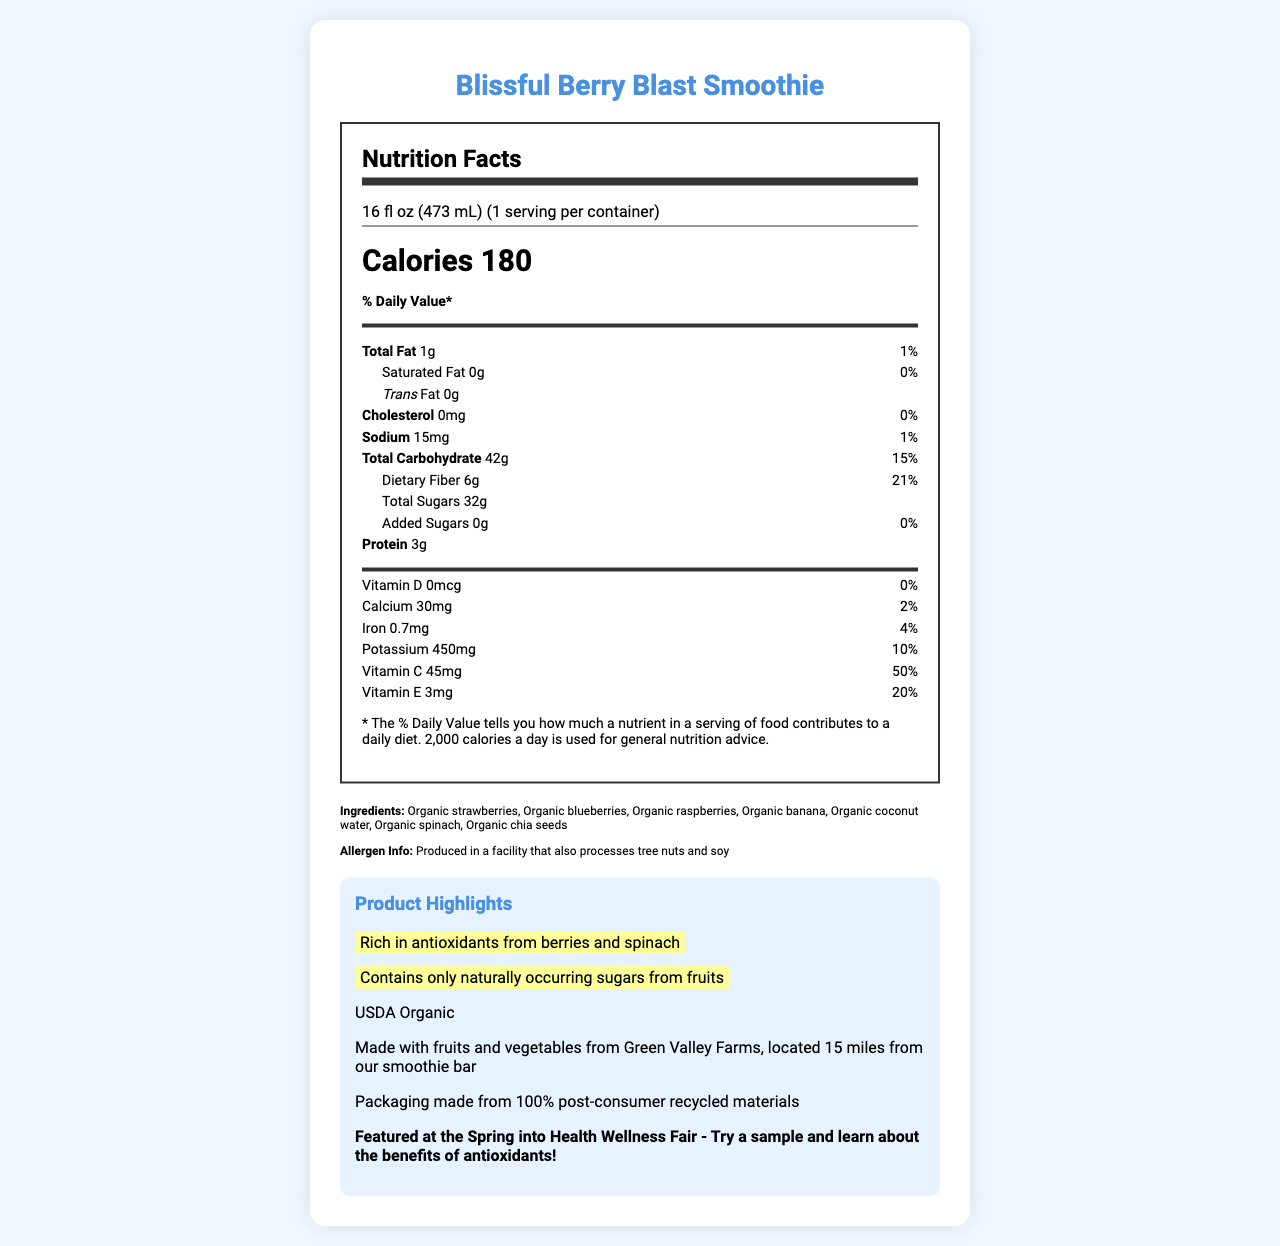what is the serving size for the Blissful Berry Blast Smoothie? The document states that the serving size is 16 fl oz (473 mL).
Answer: 16 fl oz (473 mL) how many calories are in one serving of the smoothie? The calorie count per serving is noted as 180 in the document.
Answer: 180 what is the % daily value of dietary fiber in one serving? The document lists that one serving contains 21% of the daily value of dietary fiber.
Answer: 21% are there any added sugars in the smoothie? The document specifies that the amount of added sugars is 0g, which corresponds to 0% of the daily value.
Answer: No which ingredients in the smoothie contribute to its antioxidant content? The document highlights that the smoothie is rich in antioxidants from berries and spinach.
Answer: Organic strawberries, organic blueberries, organic raspberries, organic spinach where are the fruits and vegetables sourced from for this product? The document mentions that the fruits and vegetables are sourced from Green Valley Farms.
Answer: Green Valley Farms how many grams of protein are in one serving of the smoothie? The document states that there are 3 grams of protein per serving.
Answer: 3g which nutrient has the highest % daily value in the smoothie? A. Vitamin D B. Vitamin C C. Iron D. Vitamin E Vitamin C has a % daily value of 50%, which is the highest among the listed nutrients.
Answer: B. Vitamin C what is the amount of calcium in one serving? A. 10mg B. 20mg C. 30mg D. 40mg According to the document, the amount of calcium in one serving is 30mg.
Answer: C. 30mg does the smoothie contain any cholesterol? The document indicates 0mg of cholesterol, meaning there is no cholesterol in the product.
Answer: No describe the main idea of the document The document focuses on giving a complete nutritional profile of the smoothie, highlights its health benefits, sourcing, and environmental impact, and promotes its presence at a local wellness fair.
Answer: The document provides detailed nutritional information about the Blissful Berry Blast Smoothie, emphasizing its natural sugar content, antioxidants, and organic ingredients. It highlights the product's health benefits, local sourcing from Green Valley Farms, and its environmentally friendly packaging. The smoothie will be featured at the Spring into Health Wellness Fair. is the packaging of the smoothie environmentally friendly? The document states that the packaging is made from 100% post-consumer recycled materials, indicating it is environmentally friendly.
Answer: Yes what is the total carbohydrate content in one serving? The total carbohydrate content per serving is listed as 42g in the document.
Answer: 42g how much sodium is in one serving? The document shows that one serving contains 15mg of sodium.
Answer: 15mg what type of certification does the smoothie have? The document mentions that the Blissful Berry Blast Smoothie is USDA Organic certified.
Answer: USDA Organic what is the recommended daily calorie intake used for general nutrition advice according to the document? The document specifies that 2,000 calories a day is used for general nutrition advice.
Answer: 2,000 calories is there any information about the production facility's allergen processing? The document states that the product is produced in a facility that also processes tree nuts and soy.
Answer: Yes what is the natural sugar content in the smoothie? The document emphasizes that the smoothie contains only naturally occurring sugars from the fruits used in it.
Answer: Contains only naturally occurring sugars from fruits which vitamins have specific amounts and % daily values listed? The document lists specific amounts and % daily values for these vitamins and minerals.
Answer: Vitamin D, Calcium, Iron, Potassium, Vitamin C, Vitamin E what is the amount of vitamin E in one serving? The document indicates that each serving contains 3mg of vitamin E.
Answer: 3mg which local event will feature this smoothie? The document states that the Blissful Berry Blast Smoothie will be featured at the Spring into Health Wellness Fair.
Answer: Spring into Health Wellness Fair which of the following ingredients is NOT listed? A. Organic chia seeds B. Organic honey C. Organic spinach D. Organic strawberries The document lists organic strawberries, organic spinach, and organic chia seeds as ingredients but does not mention organic honey.
Answer: B. Organic honey what is the exact % daily value of potassium in the smoothie? The document provides that the % daily value of potassium in one serving is 10%.
Answer: 10% how much total fat is in one serving of the smoothie? The document lists the total fat content as 1g per serving.
Answer: 1g what can be inferred about the sweetness of the smoothie? The document emphasizes that it contains only naturally occurring sugars from the fruits, with no added sugars.
Answer: The sweetness of the smoothie comes from naturally occurring sugars in the fruits used. what is the name of the smoothie? The document clearly states the product name as Blissful Berry Blast Smoothie.
Answer: Blissful Berry Blast Smoothie what is the smoothie produced from? The document lists these ingredients as the components of the smoothie.
Answer: Produced from organic strawberries, blueberries, raspberries, banana, coconut water, spinach, and chia seeds. are the sugars in the smoothie artificial? The document specifies that the smoothie contains only naturally occurring sugars from the fruits, indicating there are no artificial sugars.
Answer: No 